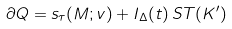<formula> <loc_0><loc_0><loc_500><loc_500>\partial Q = s _ { \tau } ( M ; v ) + I _ { \Delta } ( t ) \, S T ( K ^ { \prime } )</formula> 